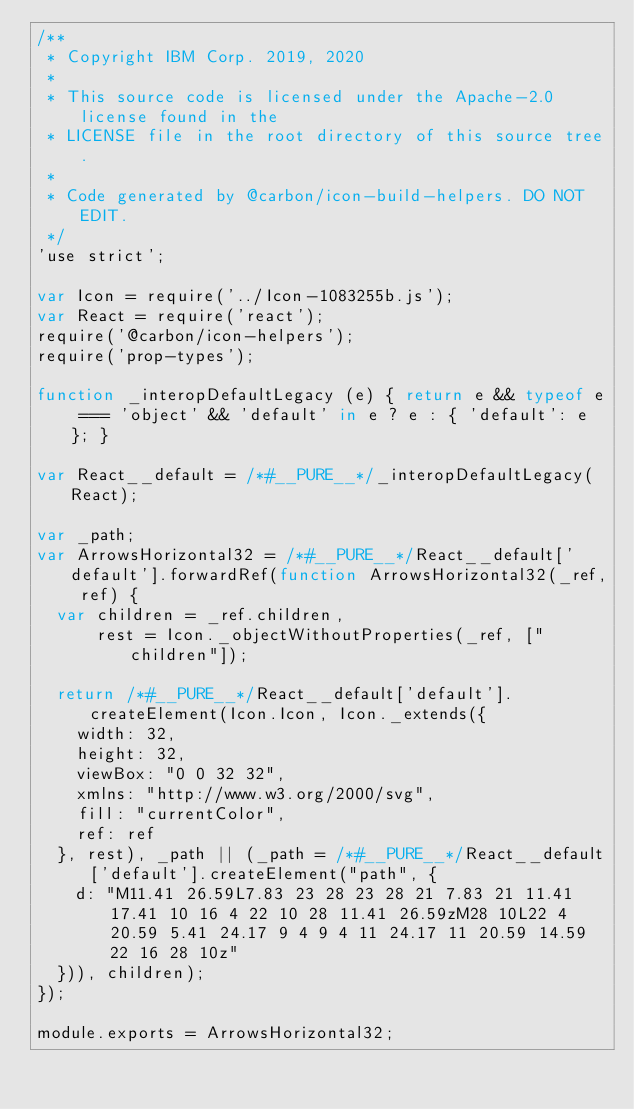<code> <loc_0><loc_0><loc_500><loc_500><_JavaScript_>/**
 * Copyright IBM Corp. 2019, 2020
 *
 * This source code is licensed under the Apache-2.0 license found in the
 * LICENSE file in the root directory of this source tree.
 *
 * Code generated by @carbon/icon-build-helpers. DO NOT EDIT.
 */
'use strict';

var Icon = require('../Icon-1083255b.js');
var React = require('react');
require('@carbon/icon-helpers');
require('prop-types');

function _interopDefaultLegacy (e) { return e && typeof e === 'object' && 'default' in e ? e : { 'default': e }; }

var React__default = /*#__PURE__*/_interopDefaultLegacy(React);

var _path;
var ArrowsHorizontal32 = /*#__PURE__*/React__default['default'].forwardRef(function ArrowsHorizontal32(_ref, ref) {
  var children = _ref.children,
      rest = Icon._objectWithoutProperties(_ref, ["children"]);

  return /*#__PURE__*/React__default['default'].createElement(Icon.Icon, Icon._extends({
    width: 32,
    height: 32,
    viewBox: "0 0 32 32",
    xmlns: "http://www.w3.org/2000/svg",
    fill: "currentColor",
    ref: ref
  }, rest), _path || (_path = /*#__PURE__*/React__default['default'].createElement("path", {
    d: "M11.41 26.59L7.83 23 28 23 28 21 7.83 21 11.41 17.41 10 16 4 22 10 28 11.41 26.59zM28 10L22 4 20.59 5.41 24.17 9 4 9 4 11 24.17 11 20.59 14.59 22 16 28 10z"
  })), children);
});

module.exports = ArrowsHorizontal32;
</code> 